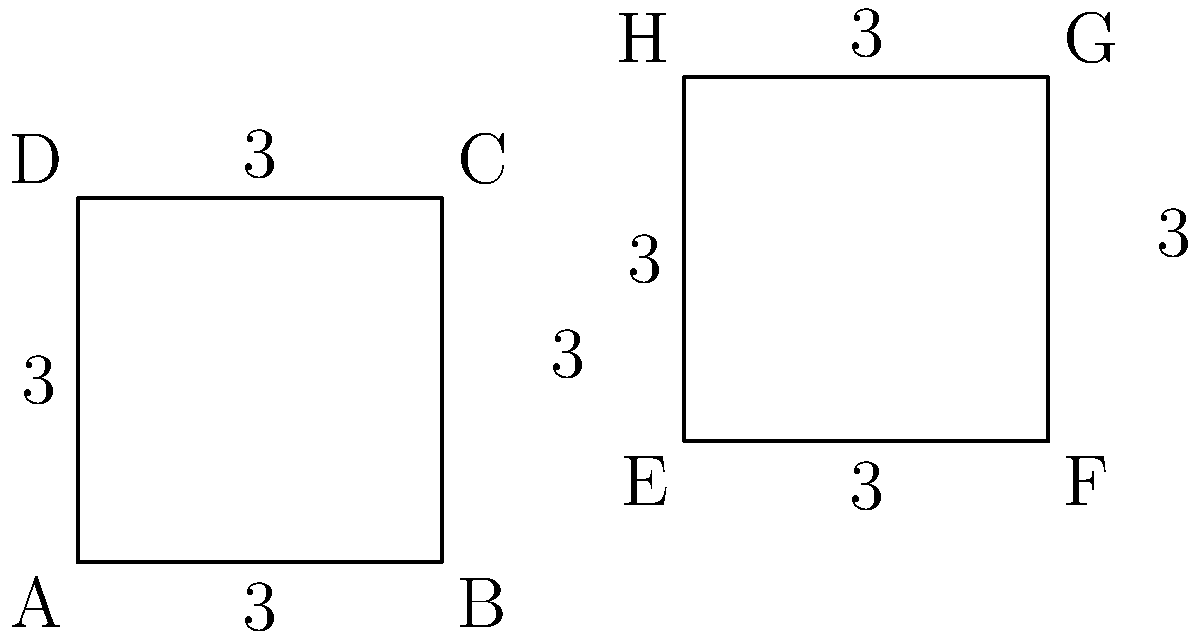As a high school counselor reviewing scholarship applications, you come across a geometry question. Two squares ABCD and EFGH are shown above. All sides of both squares measure 3 units. Are these two squares congruent? If so, explain how you would verify this to a student seeking your guidance. To determine if two polygons are congruent, we need to verify that they have the same shape and size. For squares, this means checking if they have:

1. Equal side lengths
2. Equal angles (all 90° for squares)

Step-by-step verification:

1. Side lengths:
   - Square ABCD: All sides measure 3 units
   - Square EFGH: All sides measure 3 units
   - Conclusion: All corresponding sides are equal

2. Angles:
   - Both shapes are squares, so all angles are 90°
   - Conclusion: All corresponding angles are equal

3. Congruence criteria:
   - Side-Side-Side (SSS) criterion: If three sides of one polygon are equal to three sides of another polygon, the polygons are congruent
   - In this case, all four sides are equal, which is more than sufficient to satisfy SSS

4. Additional observation:
   - Both shapes are squares with side length 3, so they are identical in shape and size

Therefore, squares ABCD and EFGH are congruent. To verify this to a student, you would explain that since all sides are equal (3 units) and all angles are 90° (being squares), the two shapes satisfy the definition of congruence: same shape and size.
Answer: Yes, congruent. Equal side lengths (3 units) and angles (90°) in both squares. 